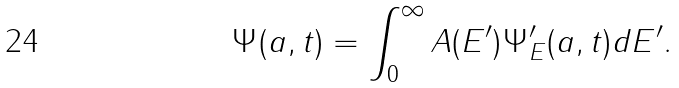<formula> <loc_0><loc_0><loc_500><loc_500>\Psi ( a , t ) = \int _ { 0 } ^ { \infty } A ( E ^ { \prime } ) \Psi _ { E } ^ { \prime } ( a , t ) d E ^ { \prime } .</formula> 